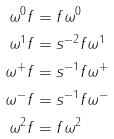Convert formula to latex. <formula><loc_0><loc_0><loc_500><loc_500>\omega ^ { 0 } f & = f \omega ^ { 0 } \\ \omega ^ { 1 } f & = s ^ { - 2 } f \omega ^ { 1 } \\ \omega ^ { + } f & = s ^ { - 1 } f \omega ^ { + } \\ \omega ^ { - } f & = s ^ { - 1 } f \omega ^ { - } \\ \omega ^ { 2 } f & = f \omega ^ { 2 }</formula> 